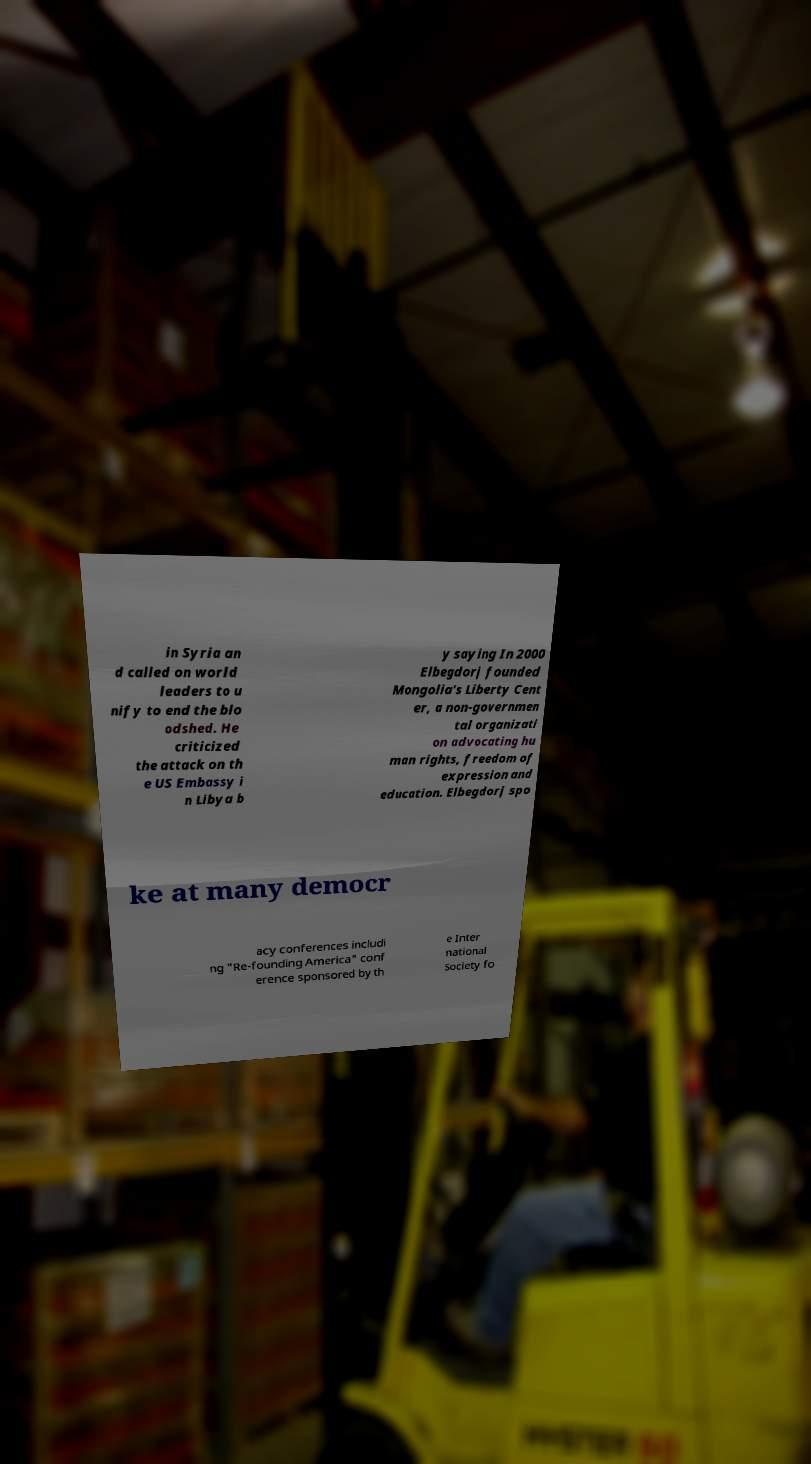What messages or text are displayed in this image? I need them in a readable, typed format. in Syria an d called on world leaders to u nify to end the blo odshed. He criticized the attack on th e US Embassy i n Libya b y saying In 2000 Elbegdorj founded Mongolia's Liberty Cent er, a non-governmen tal organizati on advocating hu man rights, freedom of expression and education. Elbegdorj spo ke at many democr acy conferences includi ng "Re-founding America" conf erence sponsored by th e Inter national Society fo 